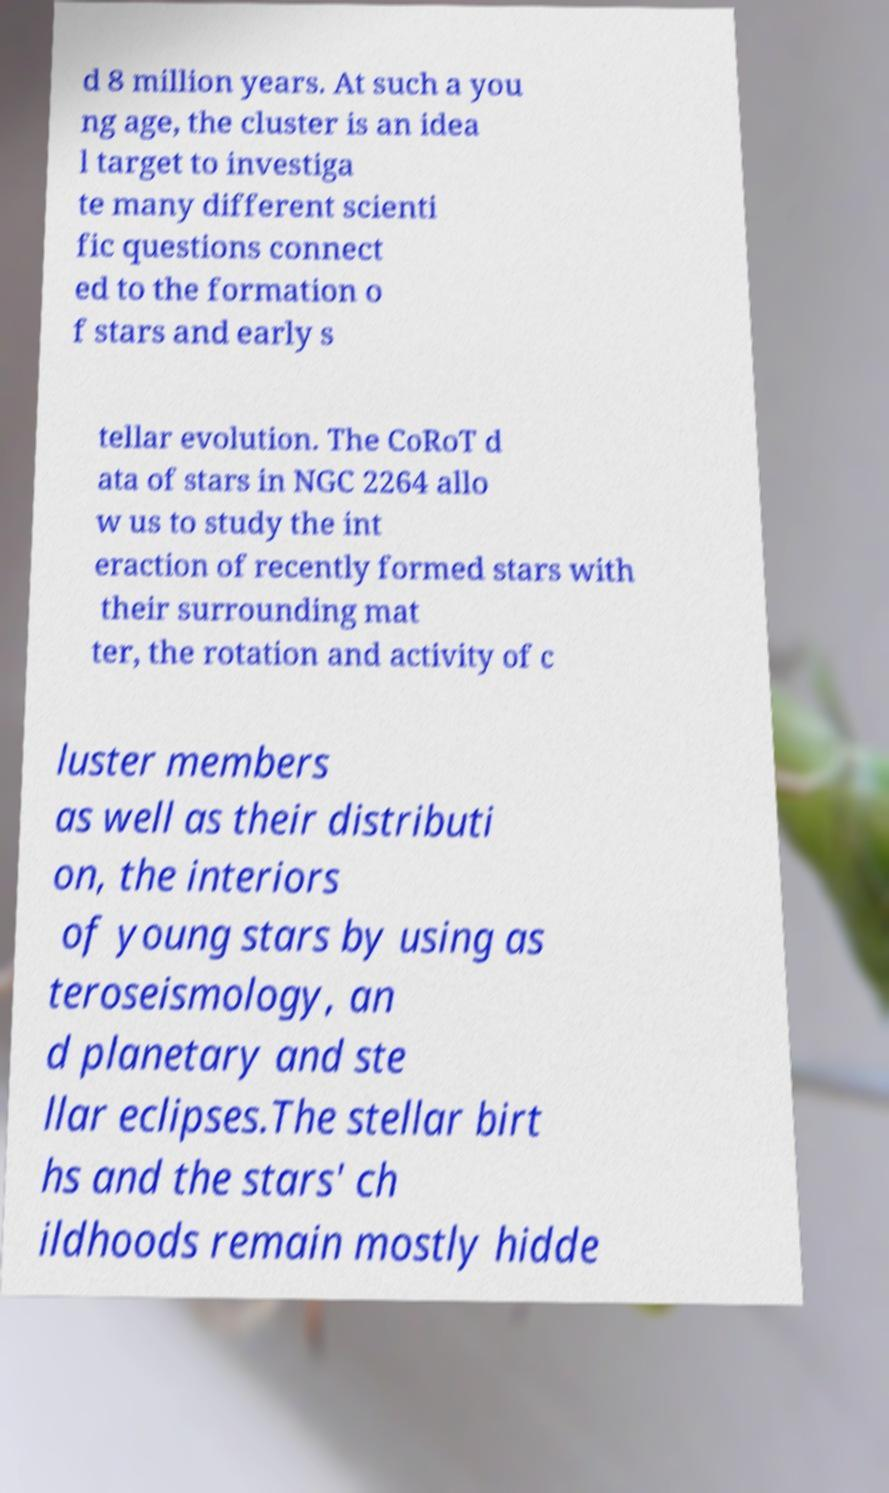Please identify and transcribe the text found in this image. d 8 million years. At such a you ng age, the cluster is an idea l target to investiga te many different scienti fic questions connect ed to the formation o f stars and early s tellar evolution. The CoRoT d ata of stars in NGC 2264 allo w us to study the int eraction of recently formed stars with their surrounding mat ter, the rotation and activity of c luster members as well as their distributi on, the interiors of young stars by using as teroseismology, an d planetary and ste llar eclipses.The stellar birt hs and the stars' ch ildhoods remain mostly hidde 